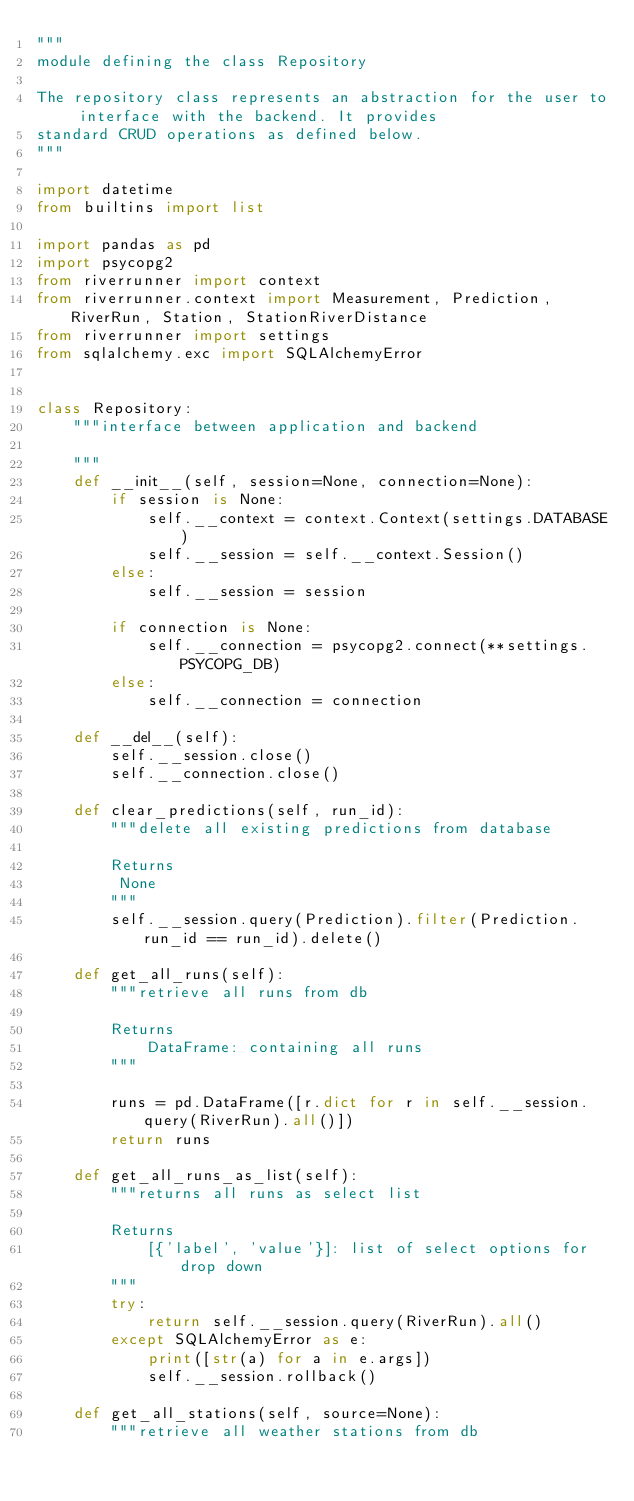Convert code to text. <code><loc_0><loc_0><loc_500><loc_500><_Python_>"""
module defining the class Repository

The repository class represents an abstraction for the user to interface with the backend. It provides
standard CRUD operations as defined below.
"""

import datetime
from builtins import list

import pandas as pd
import psycopg2
from riverrunner import context
from riverrunner.context import Measurement, Prediction, RiverRun, Station, StationRiverDistance
from riverrunner import settings
from sqlalchemy.exc import SQLAlchemyError


class Repository:
    """interface between application and backend

    """
    def __init__(self, session=None, connection=None):
        if session is None:
            self.__context = context.Context(settings.DATABASE)
            self.__session = self.__context.Session()
        else:
            self.__session = session

        if connection is None:
            self.__connection = psycopg2.connect(**settings.PSYCOPG_DB)
        else:
            self.__connection = connection

    def __del__(self):
        self.__session.close()
        self.__connection.close()

    def clear_predictions(self, run_id):
        """delete all existing predictions from database

        Returns
         None
        """
        self.__session.query(Prediction).filter(Prediction.run_id == run_id).delete()

    def get_all_runs(self):
        """retrieve all runs from db

        Returns
            DataFrame: containing all runs
        """

        runs = pd.DataFrame([r.dict for r in self.__session.query(RiverRun).all()])
        return runs

    def get_all_runs_as_list(self):
        """returns all runs as select list

        Returns
            [{'label', 'value'}]: list of select options for drop down
        """
        try:
            return self.__session.query(RiverRun).all()
        except SQLAlchemyError as e:
            print([str(a) for a in e.args])
            self.__session.rollback()

    def get_all_stations(self, source=None):
        """retrieve all weather stations from db
</code> 